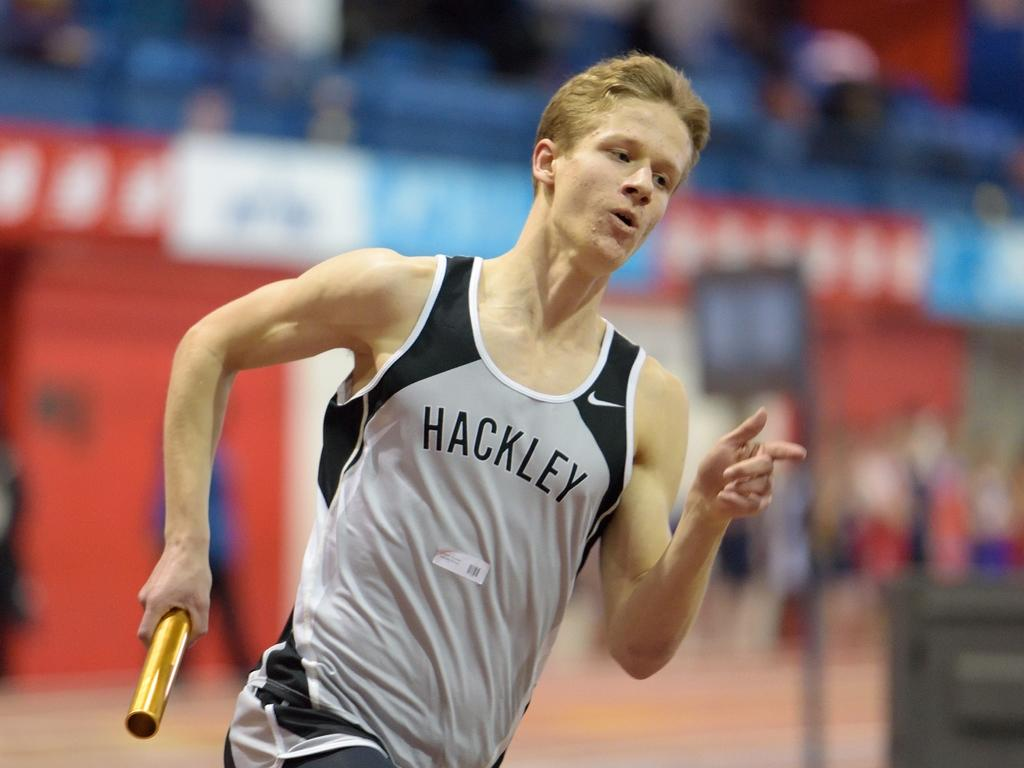<image>
Create a compact narrative representing the image presented. A runner with the name Hackley on his tank top is running on a track. 